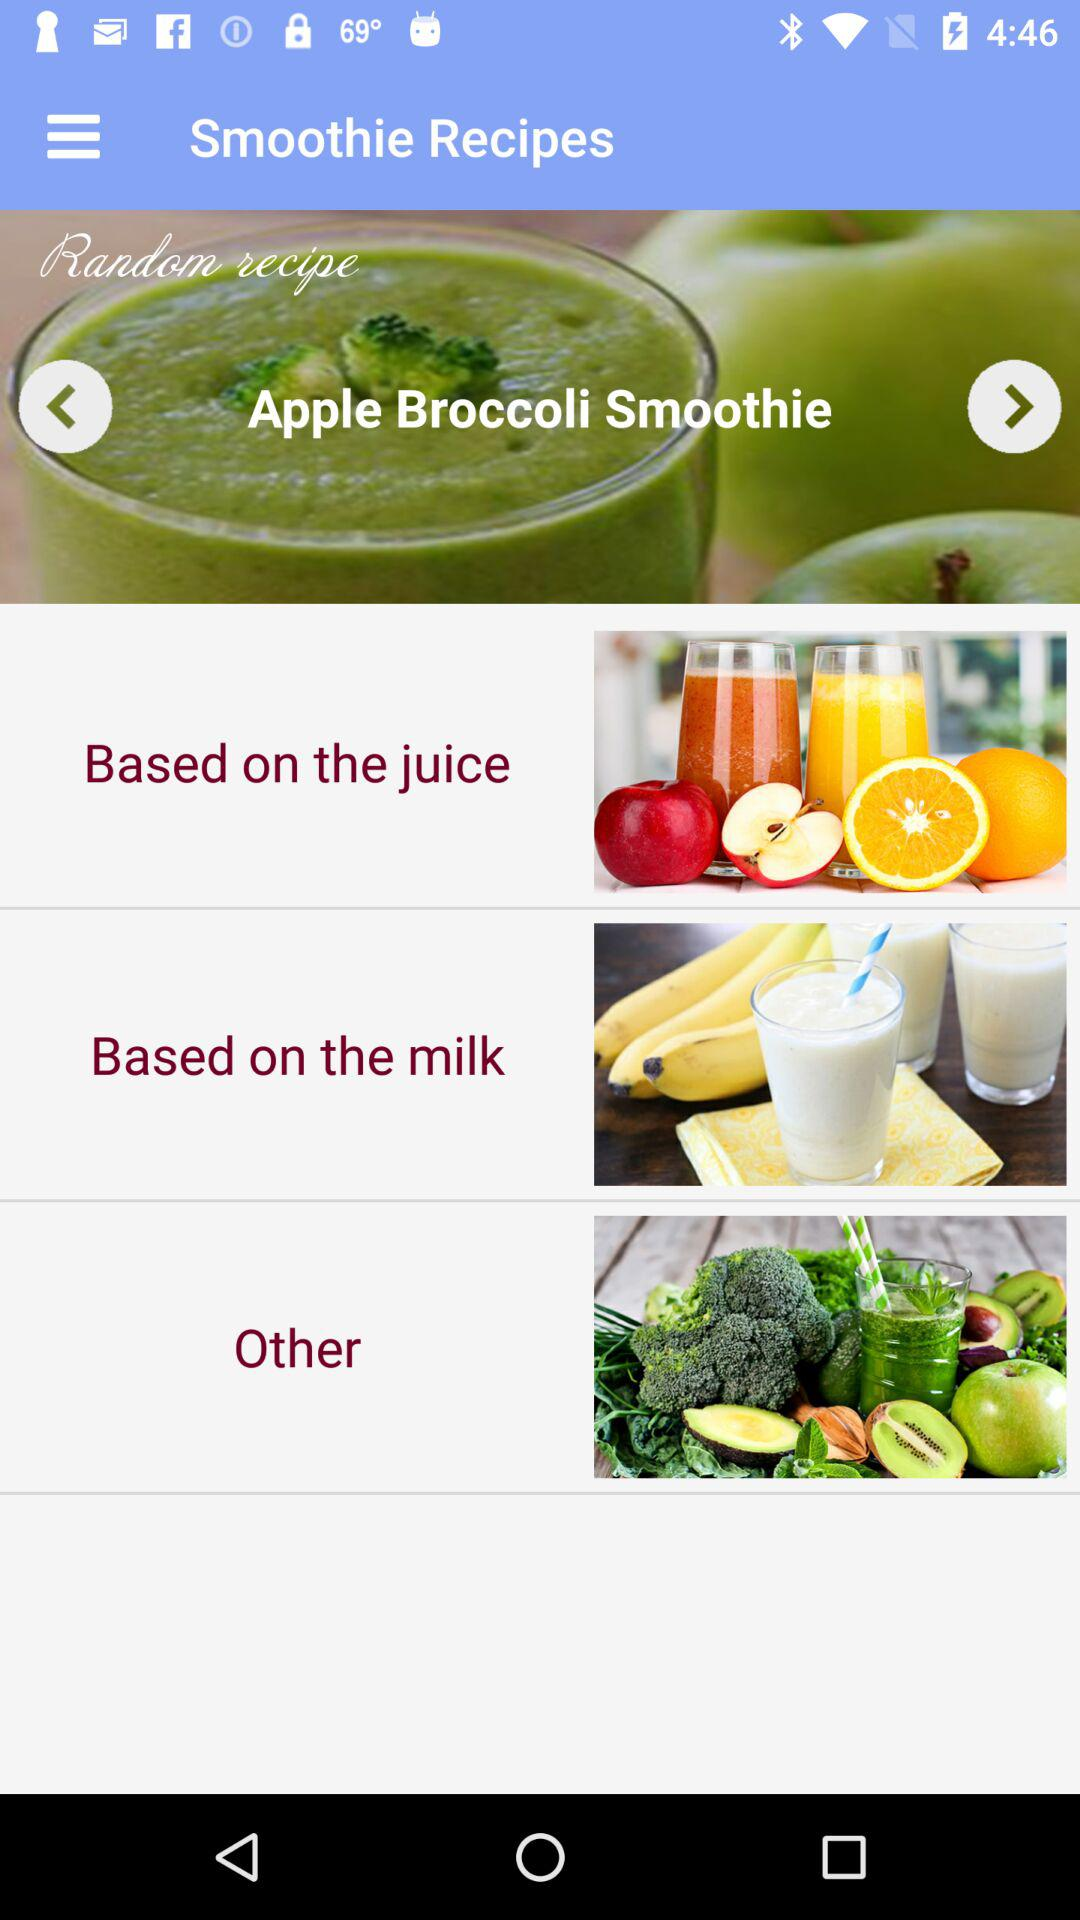How many smoothie recipes are based on juice?
Answer the question using a single word or phrase. 1 